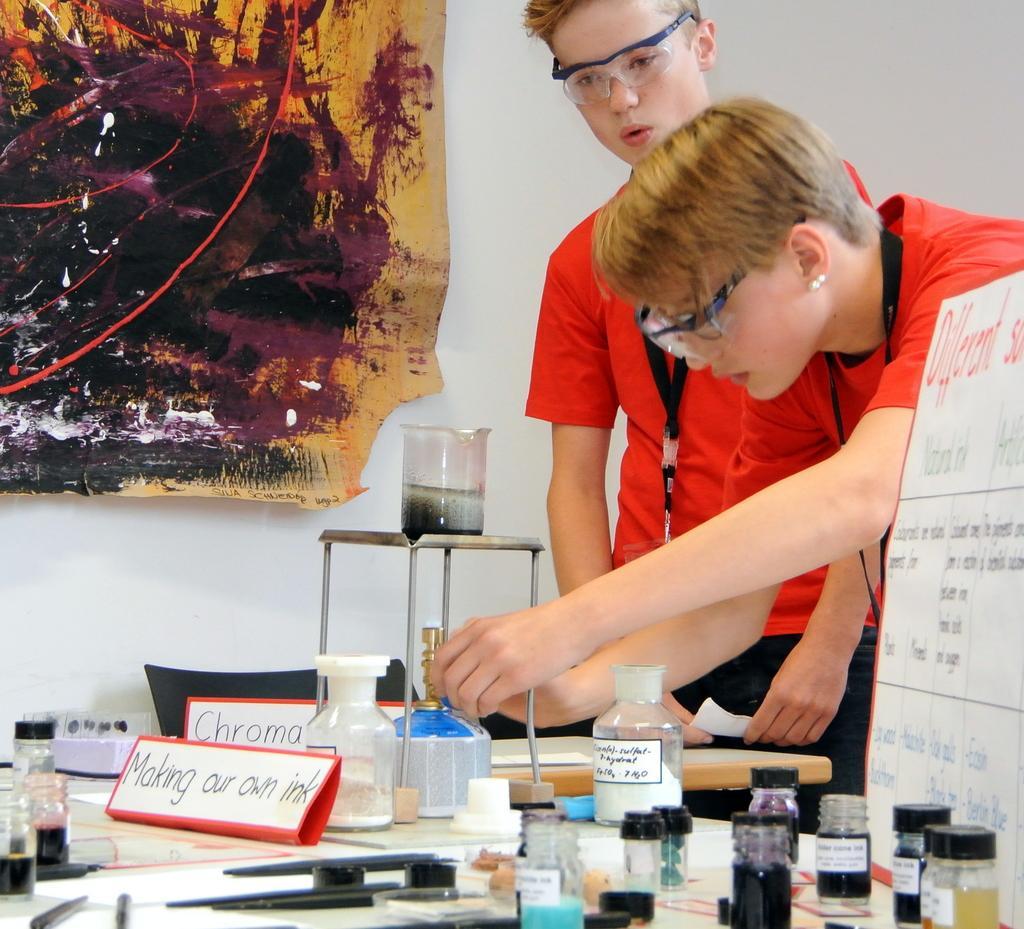Could you give a brief overview of what you see in this image? In this image we can see two people standing.. One person is holding a cylinder in his hands. In the foreground of the image we can see some bottles, pens and a glass placed on a stand. At the top of the image we can see a painting on the wall. 